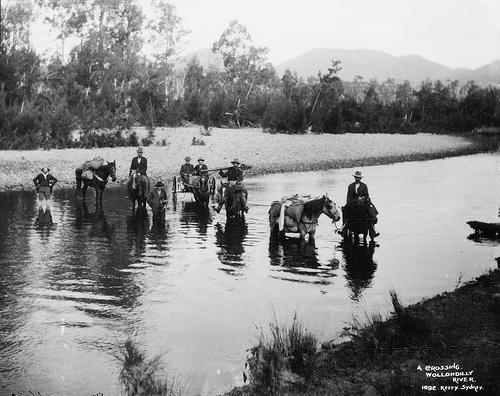How many horses are shown?
Give a very brief answer. 6. 